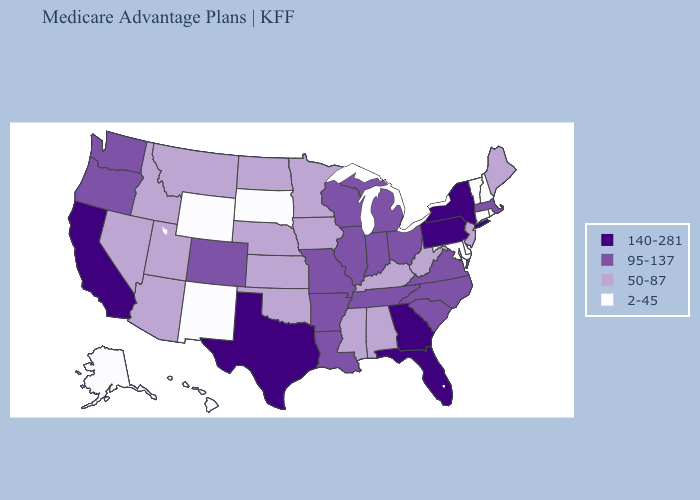Name the states that have a value in the range 95-137?
Short answer required. Arkansas, Colorado, Illinois, Indiana, Louisiana, Massachusetts, Michigan, Missouri, North Carolina, Ohio, Oregon, South Carolina, Tennessee, Virginia, Washington, Wisconsin. Does Florida have the lowest value in the South?
Concise answer only. No. Name the states that have a value in the range 50-87?
Quick response, please. Alabama, Arizona, Iowa, Idaho, Kansas, Kentucky, Maine, Minnesota, Mississippi, Montana, North Dakota, Nebraska, New Jersey, Nevada, Oklahoma, Utah, West Virginia. Which states hav the highest value in the West?
Short answer required. California. What is the highest value in the Northeast ?
Answer briefly. 140-281. Name the states that have a value in the range 95-137?
Answer briefly. Arkansas, Colorado, Illinois, Indiana, Louisiana, Massachusetts, Michigan, Missouri, North Carolina, Ohio, Oregon, South Carolina, Tennessee, Virginia, Washington, Wisconsin. Does Ohio have the highest value in the USA?
Keep it brief. No. What is the value of Michigan?
Be succinct. 95-137. Does Maryland have the highest value in the South?
Short answer required. No. What is the highest value in states that border New Mexico?
Answer briefly. 140-281. How many symbols are there in the legend?
Be succinct. 4. Does Massachusetts have the highest value in the Northeast?
Short answer required. No. Does Wyoming have the lowest value in the USA?
Concise answer only. Yes. Which states have the highest value in the USA?
Write a very short answer. California, Florida, Georgia, New York, Pennsylvania, Texas. Name the states that have a value in the range 2-45?
Concise answer only. Alaska, Connecticut, Delaware, Hawaii, Maryland, New Hampshire, New Mexico, Rhode Island, South Dakota, Vermont, Wyoming. 